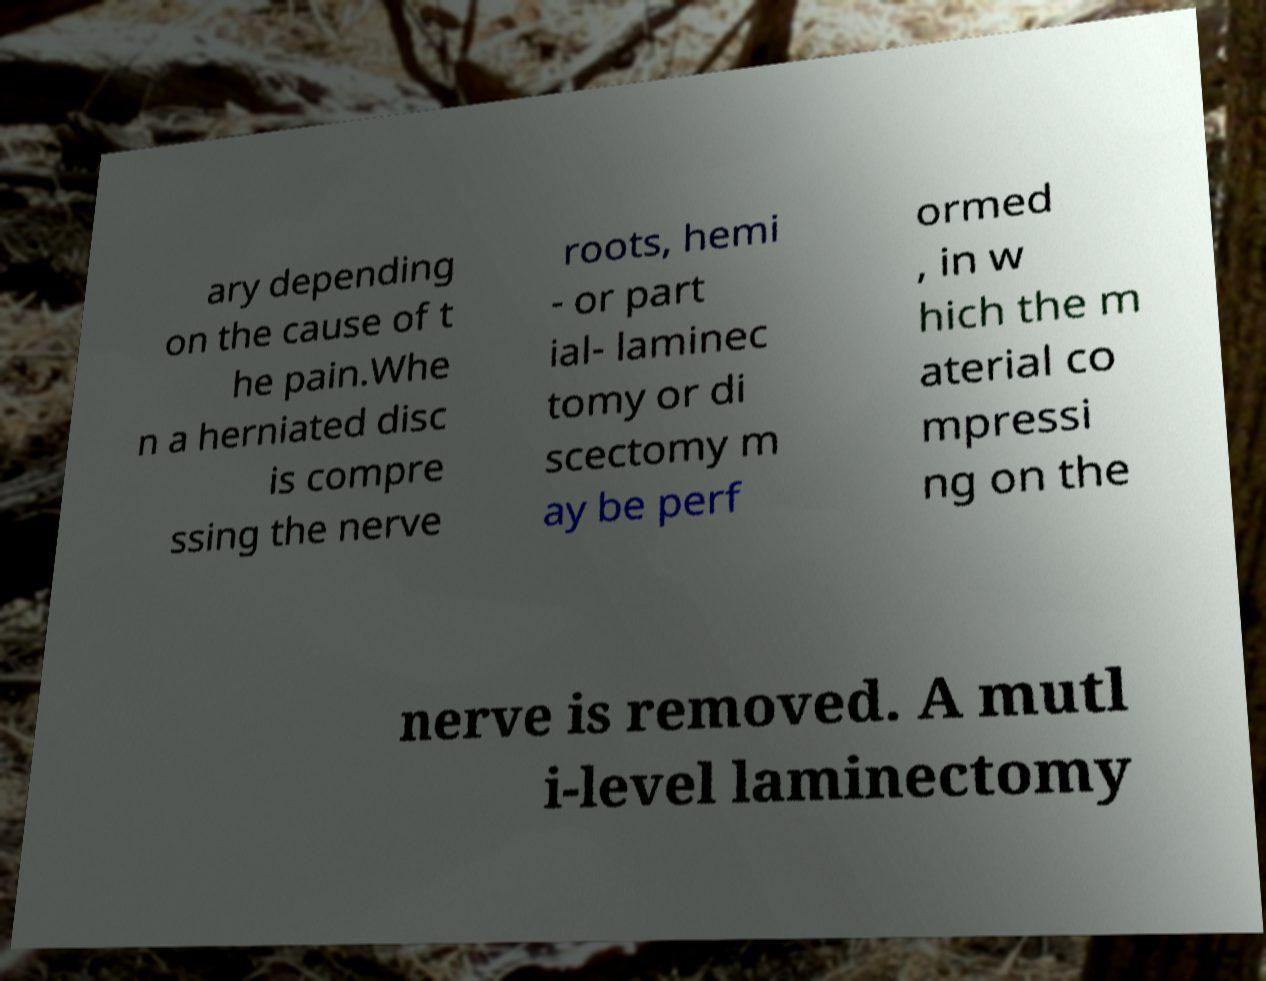Can you read and provide the text displayed in the image?This photo seems to have some interesting text. Can you extract and type it out for me? ary depending on the cause of t he pain.Whe n a herniated disc is compre ssing the nerve roots, hemi - or part ial- laminec tomy or di scectomy m ay be perf ormed , in w hich the m aterial co mpressi ng on the nerve is removed. A mutl i-level laminectomy 